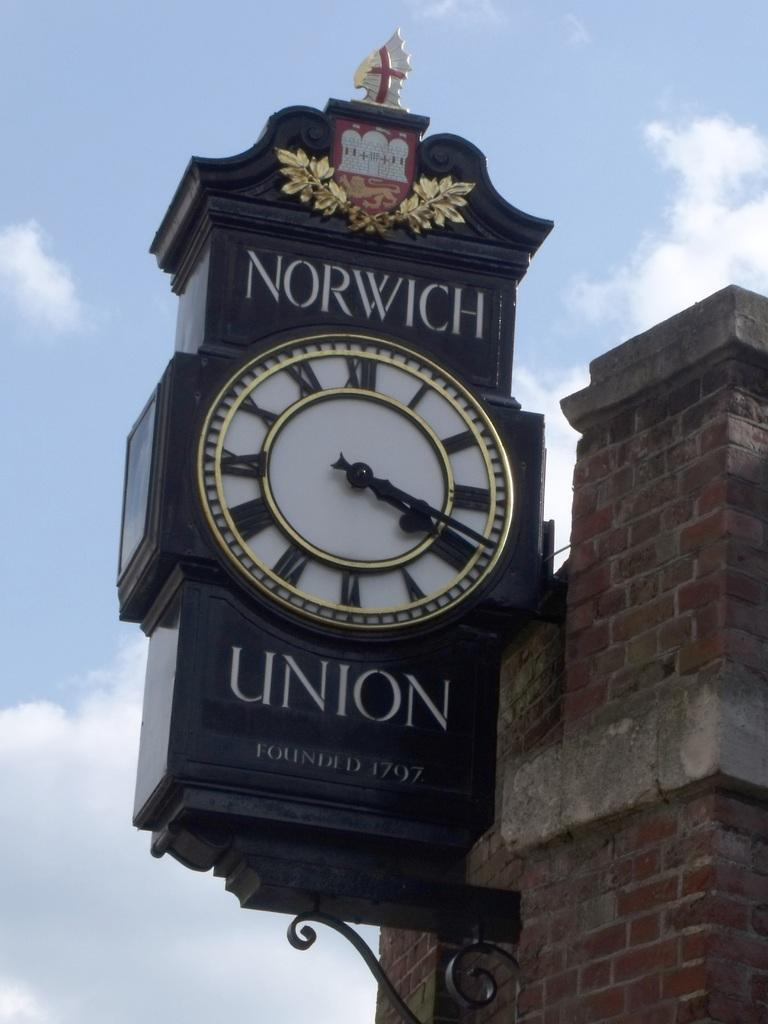Provide a one-sentence caption for the provided image. The clock on the corner said it was 4:20 pm. 